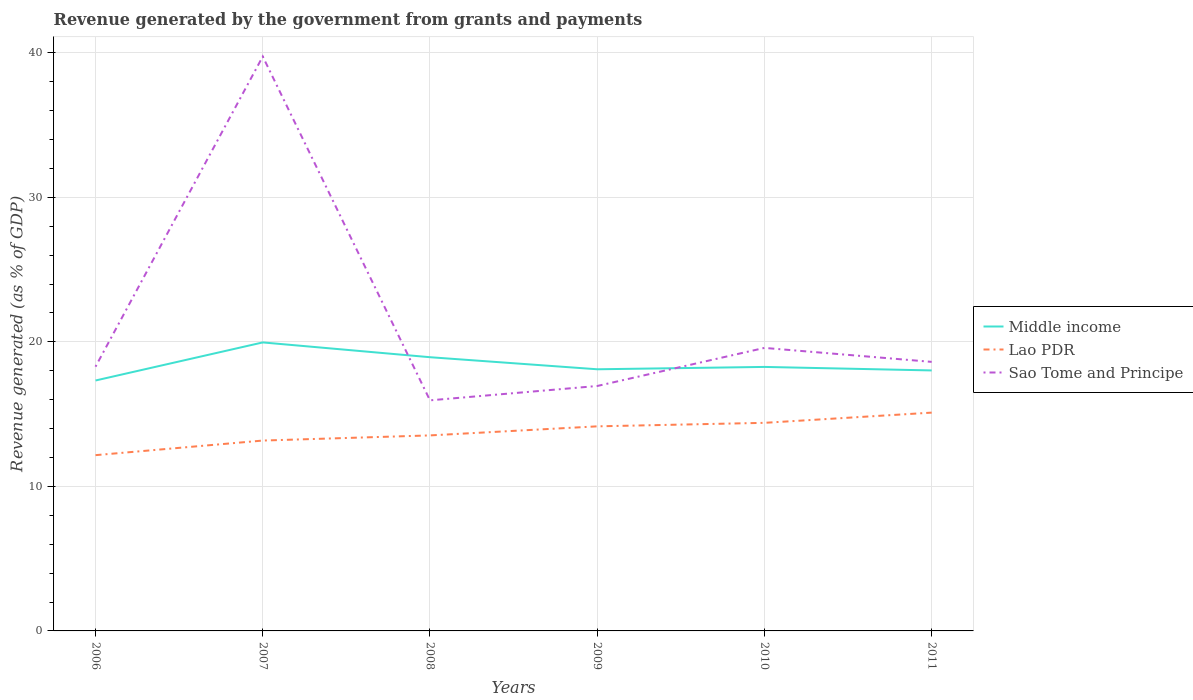How many different coloured lines are there?
Your answer should be very brief. 3. Is the number of lines equal to the number of legend labels?
Make the answer very short. Yes. Across all years, what is the maximum revenue generated by the government in Lao PDR?
Your response must be concise. 12.16. What is the total revenue generated by the government in Sao Tome and Principe in the graph?
Provide a succinct answer. 0.97. What is the difference between the highest and the second highest revenue generated by the government in Middle income?
Your answer should be compact. 2.63. Is the revenue generated by the government in Lao PDR strictly greater than the revenue generated by the government in Sao Tome and Principe over the years?
Ensure brevity in your answer.  Yes. What is the difference between two consecutive major ticks on the Y-axis?
Keep it short and to the point. 10. Are the values on the major ticks of Y-axis written in scientific E-notation?
Your answer should be compact. No. Does the graph contain grids?
Offer a very short reply. Yes. Where does the legend appear in the graph?
Ensure brevity in your answer.  Center right. What is the title of the graph?
Provide a succinct answer. Revenue generated by the government from grants and payments. Does "Isle of Man" appear as one of the legend labels in the graph?
Offer a very short reply. No. What is the label or title of the X-axis?
Provide a short and direct response. Years. What is the label or title of the Y-axis?
Your answer should be compact. Revenue generated (as % of GDP). What is the Revenue generated (as % of GDP) of Middle income in 2006?
Provide a succinct answer. 17.33. What is the Revenue generated (as % of GDP) of Lao PDR in 2006?
Keep it short and to the point. 12.16. What is the Revenue generated (as % of GDP) in Sao Tome and Principe in 2006?
Your answer should be compact. 18.28. What is the Revenue generated (as % of GDP) in Middle income in 2007?
Offer a very short reply. 19.96. What is the Revenue generated (as % of GDP) in Lao PDR in 2007?
Make the answer very short. 13.17. What is the Revenue generated (as % of GDP) in Sao Tome and Principe in 2007?
Give a very brief answer. 39.74. What is the Revenue generated (as % of GDP) in Middle income in 2008?
Give a very brief answer. 18.94. What is the Revenue generated (as % of GDP) of Lao PDR in 2008?
Your response must be concise. 13.53. What is the Revenue generated (as % of GDP) of Sao Tome and Principe in 2008?
Your answer should be very brief. 15.95. What is the Revenue generated (as % of GDP) in Middle income in 2009?
Provide a succinct answer. 18.1. What is the Revenue generated (as % of GDP) of Lao PDR in 2009?
Keep it short and to the point. 14.15. What is the Revenue generated (as % of GDP) of Sao Tome and Principe in 2009?
Give a very brief answer. 16.95. What is the Revenue generated (as % of GDP) in Middle income in 2010?
Your answer should be very brief. 18.26. What is the Revenue generated (as % of GDP) in Lao PDR in 2010?
Ensure brevity in your answer.  14.4. What is the Revenue generated (as % of GDP) in Sao Tome and Principe in 2010?
Your answer should be very brief. 19.58. What is the Revenue generated (as % of GDP) of Middle income in 2011?
Offer a terse response. 18.02. What is the Revenue generated (as % of GDP) in Lao PDR in 2011?
Your response must be concise. 15.1. What is the Revenue generated (as % of GDP) of Sao Tome and Principe in 2011?
Provide a short and direct response. 18.61. Across all years, what is the maximum Revenue generated (as % of GDP) in Middle income?
Provide a succinct answer. 19.96. Across all years, what is the maximum Revenue generated (as % of GDP) in Lao PDR?
Provide a succinct answer. 15.1. Across all years, what is the maximum Revenue generated (as % of GDP) in Sao Tome and Principe?
Provide a short and direct response. 39.74. Across all years, what is the minimum Revenue generated (as % of GDP) in Middle income?
Your response must be concise. 17.33. Across all years, what is the minimum Revenue generated (as % of GDP) in Lao PDR?
Ensure brevity in your answer.  12.16. Across all years, what is the minimum Revenue generated (as % of GDP) of Sao Tome and Principe?
Provide a short and direct response. 15.95. What is the total Revenue generated (as % of GDP) in Middle income in the graph?
Make the answer very short. 110.61. What is the total Revenue generated (as % of GDP) in Lao PDR in the graph?
Give a very brief answer. 82.51. What is the total Revenue generated (as % of GDP) in Sao Tome and Principe in the graph?
Offer a terse response. 129.11. What is the difference between the Revenue generated (as % of GDP) of Middle income in 2006 and that in 2007?
Your answer should be compact. -2.63. What is the difference between the Revenue generated (as % of GDP) in Lao PDR in 2006 and that in 2007?
Keep it short and to the point. -1.01. What is the difference between the Revenue generated (as % of GDP) in Sao Tome and Principe in 2006 and that in 2007?
Your answer should be compact. -21.46. What is the difference between the Revenue generated (as % of GDP) in Middle income in 2006 and that in 2008?
Offer a terse response. -1.61. What is the difference between the Revenue generated (as % of GDP) in Lao PDR in 2006 and that in 2008?
Offer a very short reply. -1.37. What is the difference between the Revenue generated (as % of GDP) in Sao Tome and Principe in 2006 and that in 2008?
Keep it short and to the point. 2.33. What is the difference between the Revenue generated (as % of GDP) in Middle income in 2006 and that in 2009?
Your answer should be compact. -0.78. What is the difference between the Revenue generated (as % of GDP) in Lao PDR in 2006 and that in 2009?
Offer a very short reply. -1.99. What is the difference between the Revenue generated (as % of GDP) of Sao Tome and Principe in 2006 and that in 2009?
Ensure brevity in your answer.  1.33. What is the difference between the Revenue generated (as % of GDP) of Middle income in 2006 and that in 2010?
Give a very brief answer. -0.94. What is the difference between the Revenue generated (as % of GDP) in Lao PDR in 2006 and that in 2010?
Your response must be concise. -2.24. What is the difference between the Revenue generated (as % of GDP) in Sao Tome and Principe in 2006 and that in 2010?
Offer a very short reply. -1.3. What is the difference between the Revenue generated (as % of GDP) of Middle income in 2006 and that in 2011?
Offer a terse response. -0.7. What is the difference between the Revenue generated (as % of GDP) in Lao PDR in 2006 and that in 2011?
Make the answer very short. -2.94. What is the difference between the Revenue generated (as % of GDP) in Sao Tome and Principe in 2006 and that in 2011?
Make the answer very short. -0.33. What is the difference between the Revenue generated (as % of GDP) of Middle income in 2007 and that in 2008?
Your response must be concise. 1.02. What is the difference between the Revenue generated (as % of GDP) in Lao PDR in 2007 and that in 2008?
Ensure brevity in your answer.  -0.36. What is the difference between the Revenue generated (as % of GDP) of Sao Tome and Principe in 2007 and that in 2008?
Your answer should be very brief. 23.79. What is the difference between the Revenue generated (as % of GDP) in Middle income in 2007 and that in 2009?
Your answer should be very brief. 1.86. What is the difference between the Revenue generated (as % of GDP) of Lao PDR in 2007 and that in 2009?
Offer a very short reply. -0.98. What is the difference between the Revenue generated (as % of GDP) in Sao Tome and Principe in 2007 and that in 2009?
Provide a succinct answer. 22.79. What is the difference between the Revenue generated (as % of GDP) of Middle income in 2007 and that in 2010?
Your response must be concise. 1.69. What is the difference between the Revenue generated (as % of GDP) of Lao PDR in 2007 and that in 2010?
Ensure brevity in your answer.  -1.23. What is the difference between the Revenue generated (as % of GDP) in Sao Tome and Principe in 2007 and that in 2010?
Your answer should be very brief. 20.16. What is the difference between the Revenue generated (as % of GDP) in Middle income in 2007 and that in 2011?
Offer a terse response. 1.94. What is the difference between the Revenue generated (as % of GDP) of Lao PDR in 2007 and that in 2011?
Your response must be concise. -1.93. What is the difference between the Revenue generated (as % of GDP) in Sao Tome and Principe in 2007 and that in 2011?
Keep it short and to the point. 21.13. What is the difference between the Revenue generated (as % of GDP) of Middle income in 2008 and that in 2009?
Your answer should be compact. 0.83. What is the difference between the Revenue generated (as % of GDP) in Lao PDR in 2008 and that in 2009?
Ensure brevity in your answer.  -0.63. What is the difference between the Revenue generated (as % of GDP) in Sao Tome and Principe in 2008 and that in 2009?
Your answer should be very brief. -0.99. What is the difference between the Revenue generated (as % of GDP) in Middle income in 2008 and that in 2010?
Offer a terse response. 0.67. What is the difference between the Revenue generated (as % of GDP) in Lao PDR in 2008 and that in 2010?
Offer a very short reply. -0.87. What is the difference between the Revenue generated (as % of GDP) of Sao Tome and Principe in 2008 and that in 2010?
Provide a succinct answer. -3.63. What is the difference between the Revenue generated (as % of GDP) of Middle income in 2008 and that in 2011?
Your answer should be compact. 0.92. What is the difference between the Revenue generated (as % of GDP) of Lao PDR in 2008 and that in 2011?
Provide a succinct answer. -1.58. What is the difference between the Revenue generated (as % of GDP) of Sao Tome and Principe in 2008 and that in 2011?
Provide a short and direct response. -2.66. What is the difference between the Revenue generated (as % of GDP) in Middle income in 2009 and that in 2010?
Give a very brief answer. -0.16. What is the difference between the Revenue generated (as % of GDP) of Lao PDR in 2009 and that in 2010?
Give a very brief answer. -0.24. What is the difference between the Revenue generated (as % of GDP) in Sao Tome and Principe in 2009 and that in 2010?
Your response must be concise. -2.64. What is the difference between the Revenue generated (as % of GDP) in Middle income in 2009 and that in 2011?
Keep it short and to the point. 0.08. What is the difference between the Revenue generated (as % of GDP) of Lao PDR in 2009 and that in 2011?
Keep it short and to the point. -0.95. What is the difference between the Revenue generated (as % of GDP) in Sao Tome and Principe in 2009 and that in 2011?
Your answer should be compact. -1.67. What is the difference between the Revenue generated (as % of GDP) in Middle income in 2010 and that in 2011?
Provide a short and direct response. 0.24. What is the difference between the Revenue generated (as % of GDP) in Lao PDR in 2010 and that in 2011?
Keep it short and to the point. -0.71. What is the difference between the Revenue generated (as % of GDP) in Sao Tome and Principe in 2010 and that in 2011?
Offer a very short reply. 0.97. What is the difference between the Revenue generated (as % of GDP) of Middle income in 2006 and the Revenue generated (as % of GDP) of Lao PDR in 2007?
Your response must be concise. 4.15. What is the difference between the Revenue generated (as % of GDP) of Middle income in 2006 and the Revenue generated (as % of GDP) of Sao Tome and Principe in 2007?
Offer a terse response. -22.41. What is the difference between the Revenue generated (as % of GDP) of Lao PDR in 2006 and the Revenue generated (as % of GDP) of Sao Tome and Principe in 2007?
Your answer should be compact. -27.58. What is the difference between the Revenue generated (as % of GDP) in Middle income in 2006 and the Revenue generated (as % of GDP) in Lao PDR in 2008?
Give a very brief answer. 3.8. What is the difference between the Revenue generated (as % of GDP) of Middle income in 2006 and the Revenue generated (as % of GDP) of Sao Tome and Principe in 2008?
Ensure brevity in your answer.  1.37. What is the difference between the Revenue generated (as % of GDP) of Lao PDR in 2006 and the Revenue generated (as % of GDP) of Sao Tome and Principe in 2008?
Ensure brevity in your answer.  -3.79. What is the difference between the Revenue generated (as % of GDP) of Middle income in 2006 and the Revenue generated (as % of GDP) of Lao PDR in 2009?
Offer a terse response. 3.17. What is the difference between the Revenue generated (as % of GDP) of Middle income in 2006 and the Revenue generated (as % of GDP) of Sao Tome and Principe in 2009?
Offer a terse response. 0.38. What is the difference between the Revenue generated (as % of GDP) in Lao PDR in 2006 and the Revenue generated (as % of GDP) in Sao Tome and Principe in 2009?
Make the answer very short. -4.78. What is the difference between the Revenue generated (as % of GDP) of Middle income in 2006 and the Revenue generated (as % of GDP) of Lao PDR in 2010?
Provide a short and direct response. 2.93. What is the difference between the Revenue generated (as % of GDP) in Middle income in 2006 and the Revenue generated (as % of GDP) in Sao Tome and Principe in 2010?
Offer a very short reply. -2.26. What is the difference between the Revenue generated (as % of GDP) in Lao PDR in 2006 and the Revenue generated (as % of GDP) in Sao Tome and Principe in 2010?
Your answer should be very brief. -7.42. What is the difference between the Revenue generated (as % of GDP) in Middle income in 2006 and the Revenue generated (as % of GDP) in Lao PDR in 2011?
Make the answer very short. 2.22. What is the difference between the Revenue generated (as % of GDP) of Middle income in 2006 and the Revenue generated (as % of GDP) of Sao Tome and Principe in 2011?
Give a very brief answer. -1.29. What is the difference between the Revenue generated (as % of GDP) of Lao PDR in 2006 and the Revenue generated (as % of GDP) of Sao Tome and Principe in 2011?
Your answer should be compact. -6.45. What is the difference between the Revenue generated (as % of GDP) in Middle income in 2007 and the Revenue generated (as % of GDP) in Lao PDR in 2008?
Ensure brevity in your answer.  6.43. What is the difference between the Revenue generated (as % of GDP) of Middle income in 2007 and the Revenue generated (as % of GDP) of Sao Tome and Principe in 2008?
Give a very brief answer. 4.01. What is the difference between the Revenue generated (as % of GDP) in Lao PDR in 2007 and the Revenue generated (as % of GDP) in Sao Tome and Principe in 2008?
Give a very brief answer. -2.78. What is the difference between the Revenue generated (as % of GDP) in Middle income in 2007 and the Revenue generated (as % of GDP) in Lao PDR in 2009?
Offer a terse response. 5.81. What is the difference between the Revenue generated (as % of GDP) in Middle income in 2007 and the Revenue generated (as % of GDP) in Sao Tome and Principe in 2009?
Offer a very short reply. 3.01. What is the difference between the Revenue generated (as % of GDP) of Lao PDR in 2007 and the Revenue generated (as % of GDP) of Sao Tome and Principe in 2009?
Make the answer very short. -3.77. What is the difference between the Revenue generated (as % of GDP) in Middle income in 2007 and the Revenue generated (as % of GDP) in Lao PDR in 2010?
Ensure brevity in your answer.  5.56. What is the difference between the Revenue generated (as % of GDP) in Middle income in 2007 and the Revenue generated (as % of GDP) in Sao Tome and Principe in 2010?
Provide a succinct answer. 0.38. What is the difference between the Revenue generated (as % of GDP) in Lao PDR in 2007 and the Revenue generated (as % of GDP) in Sao Tome and Principe in 2010?
Offer a very short reply. -6.41. What is the difference between the Revenue generated (as % of GDP) in Middle income in 2007 and the Revenue generated (as % of GDP) in Lao PDR in 2011?
Ensure brevity in your answer.  4.86. What is the difference between the Revenue generated (as % of GDP) in Middle income in 2007 and the Revenue generated (as % of GDP) in Sao Tome and Principe in 2011?
Your answer should be compact. 1.35. What is the difference between the Revenue generated (as % of GDP) in Lao PDR in 2007 and the Revenue generated (as % of GDP) in Sao Tome and Principe in 2011?
Provide a succinct answer. -5.44. What is the difference between the Revenue generated (as % of GDP) of Middle income in 2008 and the Revenue generated (as % of GDP) of Lao PDR in 2009?
Offer a terse response. 4.78. What is the difference between the Revenue generated (as % of GDP) in Middle income in 2008 and the Revenue generated (as % of GDP) in Sao Tome and Principe in 2009?
Provide a short and direct response. 1.99. What is the difference between the Revenue generated (as % of GDP) of Lao PDR in 2008 and the Revenue generated (as % of GDP) of Sao Tome and Principe in 2009?
Your response must be concise. -3.42. What is the difference between the Revenue generated (as % of GDP) in Middle income in 2008 and the Revenue generated (as % of GDP) in Lao PDR in 2010?
Your answer should be very brief. 4.54. What is the difference between the Revenue generated (as % of GDP) in Middle income in 2008 and the Revenue generated (as % of GDP) in Sao Tome and Principe in 2010?
Provide a succinct answer. -0.64. What is the difference between the Revenue generated (as % of GDP) of Lao PDR in 2008 and the Revenue generated (as % of GDP) of Sao Tome and Principe in 2010?
Give a very brief answer. -6.05. What is the difference between the Revenue generated (as % of GDP) in Middle income in 2008 and the Revenue generated (as % of GDP) in Lao PDR in 2011?
Make the answer very short. 3.83. What is the difference between the Revenue generated (as % of GDP) of Middle income in 2008 and the Revenue generated (as % of GDP) of Sao Tome and Principe in 2011?
Give a very brief answer. 0.32. What is the difference between the Revenue generated (as % of GDP) of Lao PDR in 2008 and the Revenue generated (as % of GDP) of Sao Tome and Principe in 2011?
Give a very brief answer. -5.09. What is the difference between the Revenue generated (as % of GDP) of Middle income in 2009 and the Revenue generated (as % of GDP) of Lao PDR in 2010?
Provide a succinct answer. 3.71. What is the difference between the Revenue generated (as % of GDP) of Middle income in 2009 and the Revenue generated (as % of GDP) of Sao Tome and Principe in 2010?
Offer a very short reply. -1.48. What is the difference between the Revenue generated (as % of GDP) of Lao PDR in 2009 and the Revenue generated (as % of GDP) of Sao Tome and Principe in 2010?
Offer a very short reply. -5.43. What is the difference between the Revenue generated (as % of GDP) of Middle income in 2009 and the Revenue generated (as % of GDP) of Lao PDR in 2011?
Make the answer very short. 3. What is the difference between the Revenue generated (as % of GDP) of Middle income in 2009 and the Revenue generated (as % of GDP) of Sao Tome and Principe in 2011?
Make the answer very short. -0.51. What is the difference between the Revenue generated (as % of GDP) in Lao PDR in 2009 and the Revenue generated (as % of GDP) in Sao Tome and Principe in 2011?
Provide a short and direct response. -4.46. What is the difference between the Revenue generated (as % of GDP) of Middle income in 2010 and the Revenue generated (as % of GDP) of Lao PDR in 2011?
Your answer should be very brief. 3.16. What is the difference between the Revenue generated (as % of GDP) in Middle income in 2010 and the Revenue generated (as % of GDP) in Sao Tome and Principe in 2011?
Make the answer very short. -0.35. What is the difference between the Revenue generated (as % of GDP) of Lao PDR in 2010 and the Revenue generated (as % of GDP) of Sao Tome and Principe in 2011?
Offer a terse response. -4.22. What is the average Revenue generated (as % of GDP) of Middle income per year?
Give a very brief answer. 18.43. What is the average Revenue generated (as % of GDP) in Lao PDR per year?
Give a very brief answer. 13.75. What is the average Revenue generated (as % of GDP) of Sao Tome and Principe per year?
Keep it short and to the point. 21.52. In the year 2006, what is the difference between the Revenue generated (as % of GDP) of Middle income and Revenue generated (as % of GDP) of Lao PDR?
Give a very brief answer. 5.16. In the year 2006, what is the difference between the Revenue generated (as % of GDP) in Middle income and Revenue generated (as % of GDP) in Sao Tome and Principe?
Offer a terse response. -0.95. In the year 2006, what is the difference between the Revenue generated (as % of GDP) of Lao PDR and Revenue generated (as % of GDP) of Sao Tome and Principe?
Your answer should be very brief. -6.12. In the year 2007, what is the difference between the Revenue generated (as % of GDP) of Middle income and Revenue generated (as % of GDP) of Lao PDR?
Keep it short and to the point. 6.79. In the year 2007, what is the difference between the Revenue generated (as % of GDP) in Middle income and Revenue generated (as % of GDP) in Sao Tome and Principe?
Ensure brevity in your answer.  -19.78. In the year 2007, what is the difference between the Revenue generated (as % of GDP) in Lao PDR and Revenue generated (as % of GDP) in Sao Tome and Principe?
Offer a terse response. -26.57. In the year 2008, what is the difference between the Revenue generated (as % of GDP) of Middle income and Revenue generated (as % of GDP) of Lao PDR?
Make the answer very short. 5.41. In the year 2008, what is the difference between the Revenue generated (as % of GDP) in Middle income and Revenue generated (as % of GDP) in Sao Tome and Principe?
Give a very brief answer. 2.98. In the year 2008, what is the difference between the Revenue generated (as % of GDP) in Lao PDR and Revenue generated (as % of GDP) in Sao Tome and Principe?
Offer a very short reply. -2.43. In the year 2009, what is the difference between the Revenue generated (as % of GDP) of Middle income and Revenue generated (as % of GDP) of Lao PDR?
Your answer should be very brief. 3.95. In the year 2009, what is the difference between the Revenue generated (as % of GDP) of Middle income and Revenue generated (as % of GDP) of Sao Tome and Principe?
Make the answer very short. 1.16. In the year 2009, what is the difference between the Revenue generated (as % of GDP) of Lao PDR and Revenue generated (as % of GDP) of Sao Tome and Principe?
Ensure brevity in your answer.  -2.79. In the year 2010, what is the difference between the Revenue generated (as % of GDP) of Middle income and Revenue generated (as % of GDP) of Lao PDR?
Ensure brevity in your answer.  3.87. In the year 2010, what is the difference between the Revenue generated (as % of GDP) of Middle income and Revenue generated (as % of GDP) of Sao Tome and Principe?
Offer a terse response. -1.32. In the year 2010, what is the difference between the Revenue generated (as % of GDP) of Lao PDR and Revenue generated (as % of GDP) of Sao Tome and Principe?
Keep it short and to the point. -5.18. In the year 2011, what is the difference between the Revenue generated (as % of GDP) of Middle income and Revenue generated (as % of GDP) of Lao PDR?
Offer a very short reply. 2.92. In the year 2011, what is the difference between the Revenue generated (as % of GDP) of Middle income and Revenue generated (as % of GDP) of Sao Tome and Principe?
Provide a short and direct response. -0.59. In the year 2011, what is the difference between the Revenue generated (as % of GDP) of Lao PDR and Revenue generated (as % of GDP) of Sao Tome and Principe?
Provide a short and direct response. -3.51. What is the ratio of the Revenue generated (as % of GDP) of Middle income in 2006 to that in 2007?
Your answer should be very brief. 0.87. What is the ratio of the Revenue generated (as % of GDP) in Lao PDR in 2006 to that in 2007?
Provide a succinct answer. 0.92. What is the ratio of the Revenue generated (as % of GDP) of Sao Tome and Principe in 2006 to that in 2007?
Offer a very short reply. 0.46. What is the ratio of the Revenue generated (as % of GDP) of Middle income in 2006 to that in 2008?
Make the answer very short. 0.91. What is the ratio of the Revenue generated (as % of GDP) in Lao PDR in 2006 to that in 2008?
Give a very brief answer. 0.9. What is the ratio of the Revenue generated (as % of GDP) of Sao Tome and Principe in 2006 to that in 2008?
Offer a terse response. 1.15. What is the ratio of the Revenue generated (as % of GDP) in Middle income in 2006 to that in 2009?
Offer a very short reply. 0.96. What is the ratio of the Revenue generated (as % of GDP) of Lao PDR in 2006 to that in 2009?
Your answer should be very brief. 0.86. What is the ratio of the Revenue generated (as % of GDP) in Sao Tome and Principe in 2006 to that in 2009?
Provide a succinct answer. 1.08. What is the ratio of the Revenue generated (as % of GDP) of Middle income in 2006 to that in 2010?
Provide a succinct answer. 0.95. What is the ratio of the Revenue generated (as % of GDP) of Lao PDR in 2006 to that in 2010?
Provide a short and direct response. 0.84. What is the ratio of the Revenue generated (as % of GDP) of Sao Tome and Principe in 2006 to that in 2010?
Give a very brief answer. 0.93. What is the ratio of the Revenue generated (as % of GDP) in Middle income in 2006 to that in 2011?
Offer a terse response. 0.96. What is the ratio of the Revenue generated (as % of GDP) of Lao PDR in 2006 to that in 2011?
Your answer should be very brief. 0.81. What is the ratio of the Revenue generated (as % of GDP) of Sao Tome and Principe in 2006 to that in 2011?
Provide a short and direct response. 0.98. What is the ratio of the Revenue generated (as % of GDP) of Middle income in 2007 to that in 2008?
Provide a succinct answer. 1.05. What is the ratio of the Revenue generated (as % of GDP) in Lao PDR in 2007 to that in 2008?
Provide a succinct answer. 0.97. What is the ratio of the Revenue generated (as % of GDP) of Sao Tome and Principe in 2007 to that in 2008?
Give a very brief answer. 2.49. What is the ratio of the Revenue generated (as % of GDP) in Middle income in 2007 to that in 2009?
Offer a terse response. 1.1. What is the ratio of the Revenue generated (as % of GDP) in Lao PDR in 2007 to that in 2009?
Your answer should be compact. 0.93. What is the ratio of the Revenue generated (as % of GDP) of Sao Tome and Principe in 2007 to that in 2009?
Your answer should be very brief. 2.35. What is the ratio of the Revenue generated (as % of GDP) in Middle income in 2007 to that in 2010?
Offer a very short reply. 1.09. What is the ratio of the Revenue generated (as % of GDP) of Lao PDR in 2007 to that in 2010?
Ensure brevity in your answer.  0.91. What is the ratio of the Revenue generated (as % of GDP) in Sao Tome and Principe in 2007 to that in 2010?
Provide a short and direct response. 2.03. What is the ratio of the Revenue generated (as % of GDP) of Middle income in 2007 to that in 2011?
Ensure brevity in your answer.  1.11. What is the ratio of the Revenue generated (as % of GDP) in Lao PDR in 2007 to that in 2011?
Make the answer very short. 0.87. What is the ratio of the Revenue generated (as % of GDP) in Sao Tome and Principe in 2007 to that in 2011?
Your response must be concise. 2.13. What is the ratio of the Revenue generated (as % of GDP) of Middle income in 2008 to that in 2009?
Give a very brief answer. 1.05. What is the ratio of the Revenue generated (as % of GDP) in Lao PDR in 2008 to that in 2009?
Offer a very short reply. 0.96. What is the ratio of the Revenue generated (as % of GDP) of Sao Tome and Principe in 2008 to that in 2009?
Provide a succinct answer. 0.94. What is the ratio of the Revenue generated (as % of GDP) of Middle income in 2008 to that in 2010?
Keep it short and to the point. 1.04. What is the ratio of the Revenue generated (as % of GDP) in Lao PDR in 2008 to that in 2010?
Offer a very short reply. 0.94. What is the ratio of the Revenue generated (as % of GDP) of Sao Tome and Principe in 2008 to that in 2010?
Provide a succinct answer. 0.81. What is the ratio of the Revenue generated (as % of GDP) of Middle income in 2008 to that in 2011?
Keep it short and to the point. 1.05. What is the ratio of the Revenue generated (as % of GDP) in Lao PDR in 2008 to that in 2011?
Keep it short and to the point. 0.9. What is the ratio of the Revenue generated (as % of GDP) of Sao Tome and Principe in 2008 to that in 2011?
Your response must be concise. 0.86. What is the ratio of the Revenue generated (as % of GDP) of Lao PDR in 2009 to that in 2010?
Your answer should be very brief. 0.98. What is the ratio of the Revenue generated (as % of GDP) in Sao Tome and Principe in 2009 to that in 2010?
Give a very brief answer. 0.87. What is the ratio of the Revenue generated (as % of GDP) of Middle income in 2009 to that in 2011?
Offer a very short reply. 1. What is the ratio of the Revenue generated (as % of GDP) of Lao PDR in 2009 to that in 2011?
Keep it short and to the point. 0.94. What is the ratio of the Revenue generated (as % of GDP) in Sao Tome and Principe in 2009 to that in 2011?
Keep it short and to the point. 0.91. What is the ratio of the Revenue generated (as % of GDP) of Middle income in 2010 to that in 2011?
Offer a terse response. 1.01. What is the ratio of the Revenue generated (as % of GDP) of Lao PDR in 2010 to that in 2011?
Your answer should be compact. 0.95. What is the ratio of the Revenue generated (as % of GDP) of Sao Tome and Principe in 2010 to that in 2011?
Your response must be concise. 1.05. What is the difference between the highest and the second highest Revenue generated (as % of GDP) of Middle income?
Your response must be concise. 1.02. What is the difference between the highest and the second highest Revenue generated (as % of GDP) in Lao PDR?
Offer a terse response. 0.71. What is the difference between the highest and the second highest Revenue generated (as % of GDP) in Sao Tome and Principe?
Your answer should be compact. 20.16. What is the difference between the highest and the lowest Revenue generated (as % of GDP) in Middle income?
Your answer should be very brief. 2.63. What is the difference between the highest and the lowest Revenue generated (as % of GDP) of Lao PDR?
Offer a very short reply. 2.94. What is the difference between the highest and the lowest Revenue generated (as % of GDP) in Sao Tome and Principe?
Make the answer very short. 23.79. 